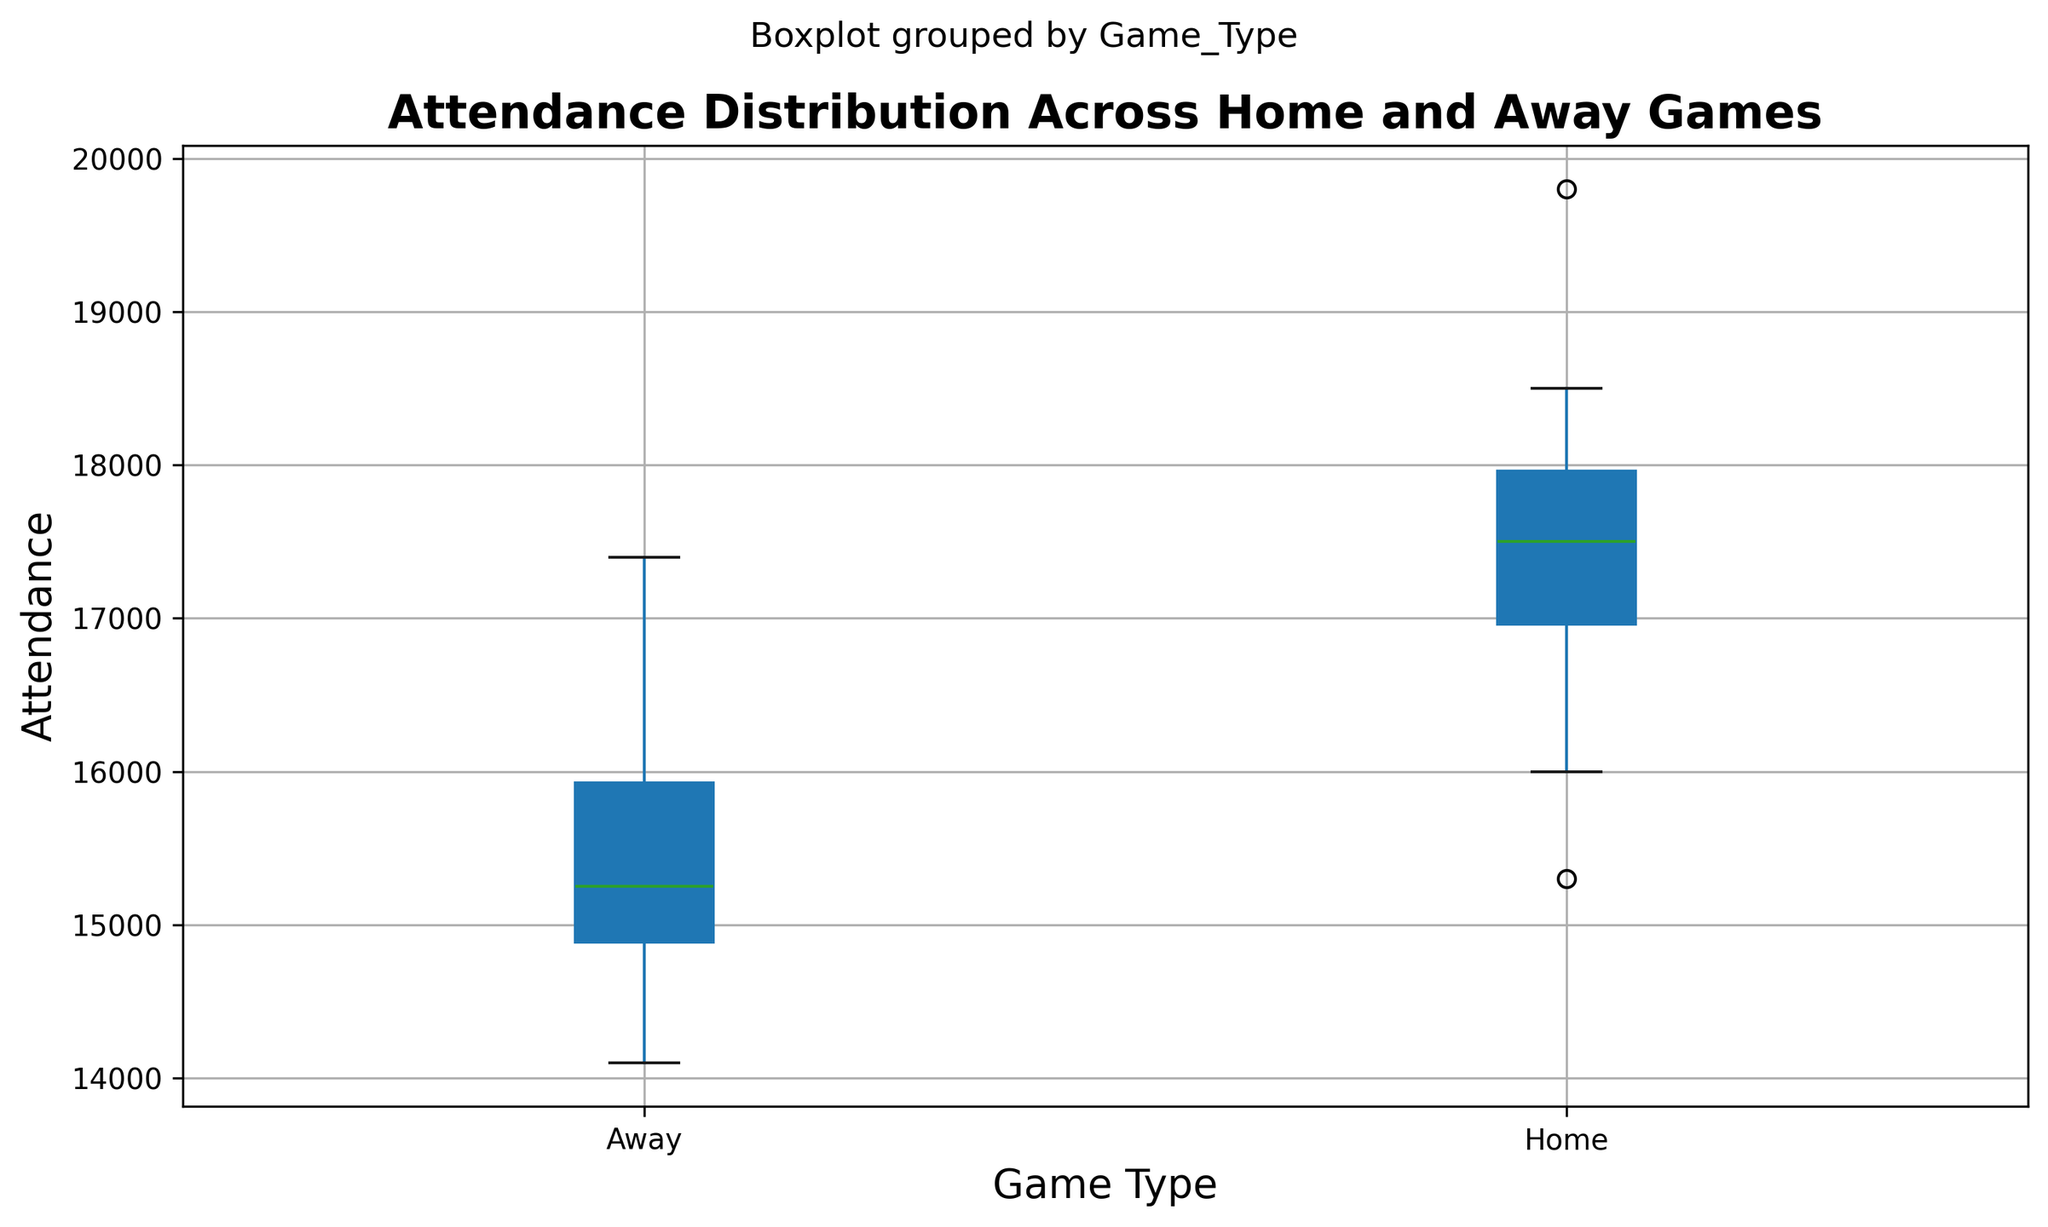What's the median attendance for home games? To find the median attendance for home games, look at the box plot's line inside the "Home" box. This line represents the median value of the data.
Answer: 17500 What's the interquartile range (IQR) for away games? The IQR is the range between the first quartile (lower edge of the box) and the third quartile (upper edge of the box) in the "Away" section of the box plot.
Answer: 15100-16000 Which type of game has a higher median attendance? To determine which game type has a higher median attendance, compare the lines inside the boxes for both home and away games. The line representing the median for home games is higher than that for away games.
Answer: Home games What is the range of attendance values for home games? The range is the difference between the maximum and minimum attendance values, which can be found at the whiskers' ends in the "Home" section.
Answer: 15300-19800 How does the spread of attendance compare between home and away games? By comparing the lengths of the boxes and whiskers for home and away games, we can infer that the spread for home games appears wider, indicating higher variability in attendance.
Answer: Home games have a wider spread What are the upper quartile values for both home and away games? The upper quartile value is represented by the upper edge of the boxes. For home games, it's around 18200; for away games, it's around 16000.
Answer: Home: 18200, Away: 16000 Which game type has more consistent attendance based on the interquartile range (IQR)? Consistency can be judged by the IQR, the smaller the IQR, the more consistent the attendance. The IQR for home games is larger than for away games, indicating less consistency.
Answer: Away games What's the difference in the median attendance between home and away games? The difference between the median attendance values for home and away games is obtained by subtracting the median value of away games from that of home games (17500 - 15100).
Answer: 2400 What is the attendance value at the lower quartile for home games? The lower quartile value, represented by the lower edge of the box in the "Home" section, is approximately 16800.
Answer: 16800 Are there any outliers in the attendance data? If so, for which type of games? Outliers, if any, would be represented by individual points outside the whiskers in the box plot. The figure doesn’t show any such outliers for either home or away games.
Answer: No outliers 